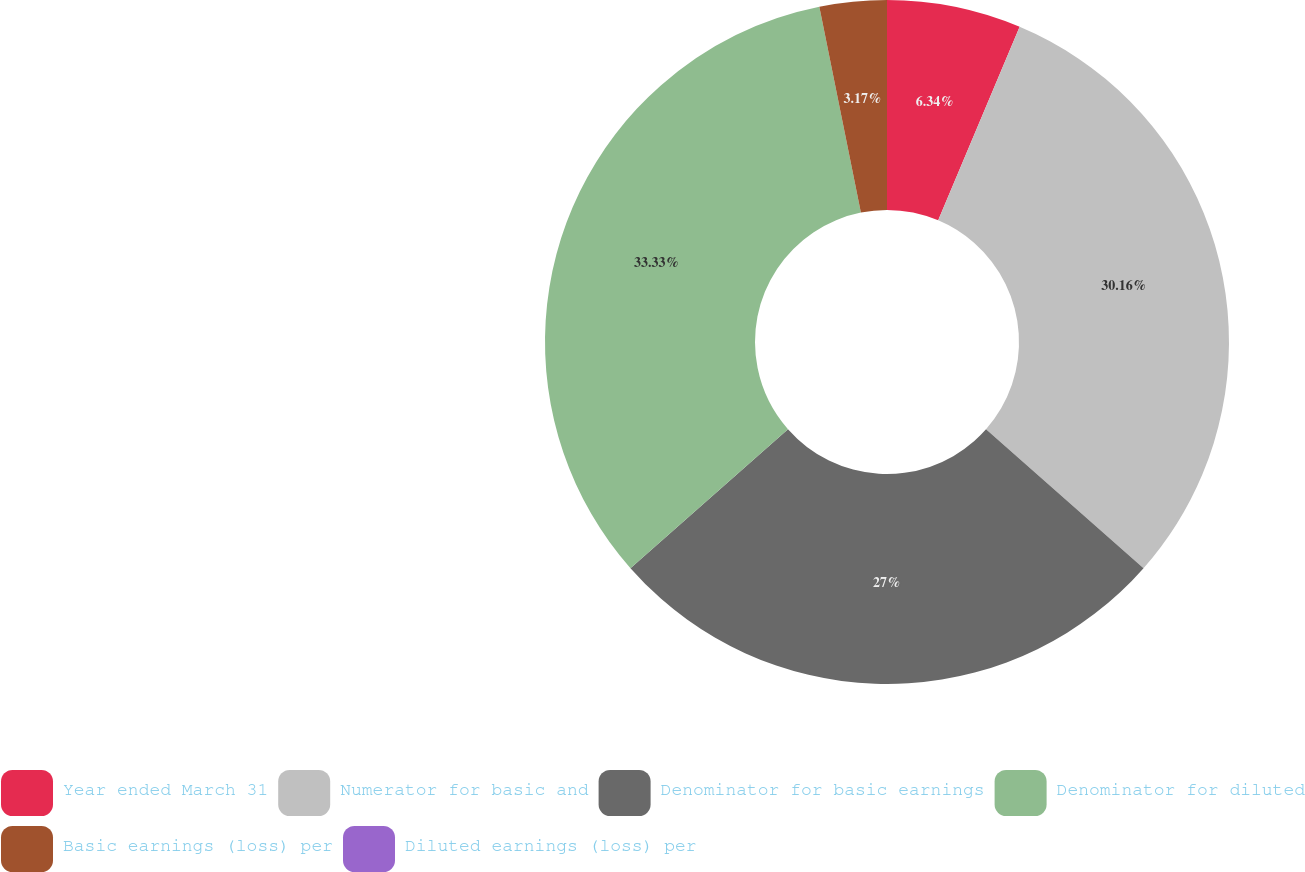Convert chart. <chart><loc_0><loc_0><loc_500><loc_500><pie_chart><fcel>Year ended March 31<fcel>Numerator for basic and<fcel>Denominator for basic earnings<fcel>Denominator for diluted<fcel>Basic earnings (loss) per<fcel>Diluted earnings (loss) per<nl><fcel>6.34%<fcel>30.16%<fcel>27.0%<fcel>33.33%<fcel>3.17%<fcel>0.0%<nl></chart> 